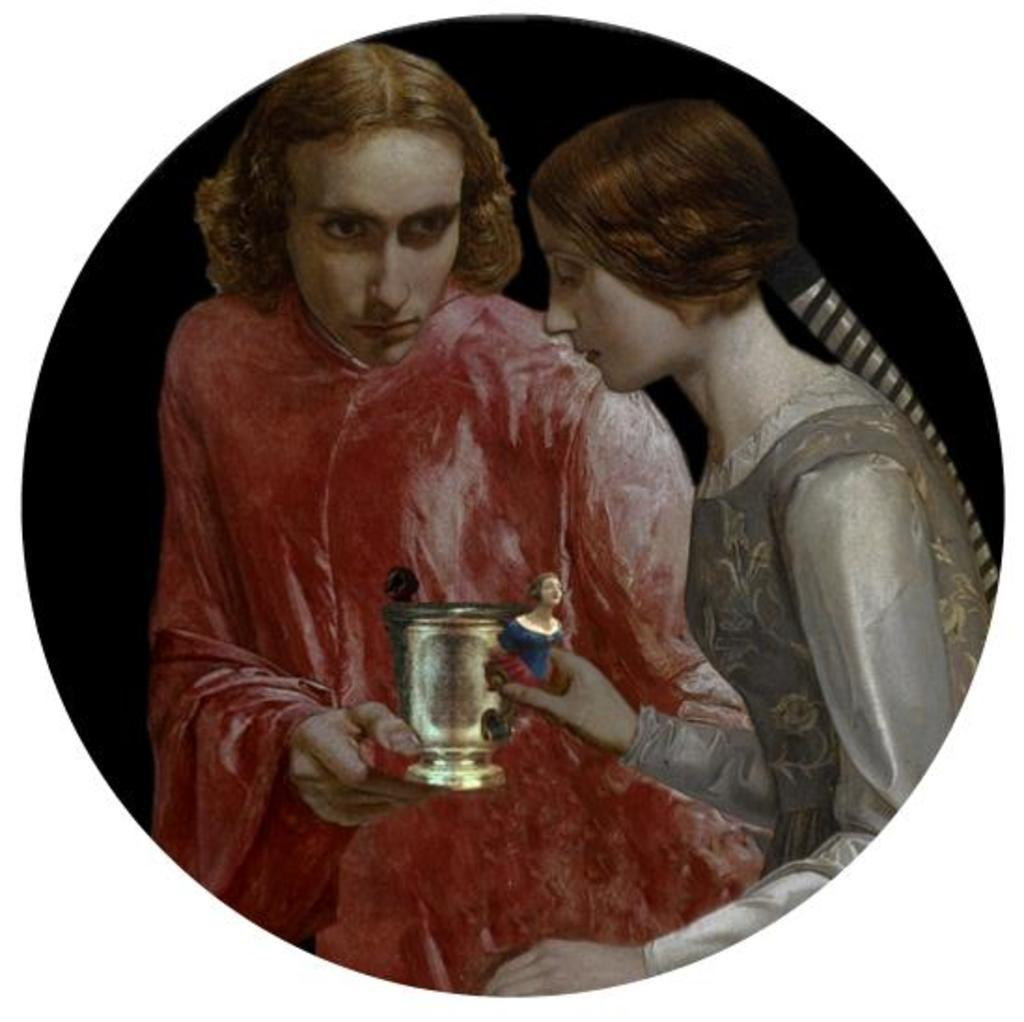What is depicted in the image? There is a painting in the image. Can you describe the scene in the painting? The painting features two people. What are the two people doing in the painting? The two people are holding an object. What type of friction can be observed between the two people holding the object in the painting? There is no friction present in the painting, as it is a static image and not a physical interaction between the two people. 